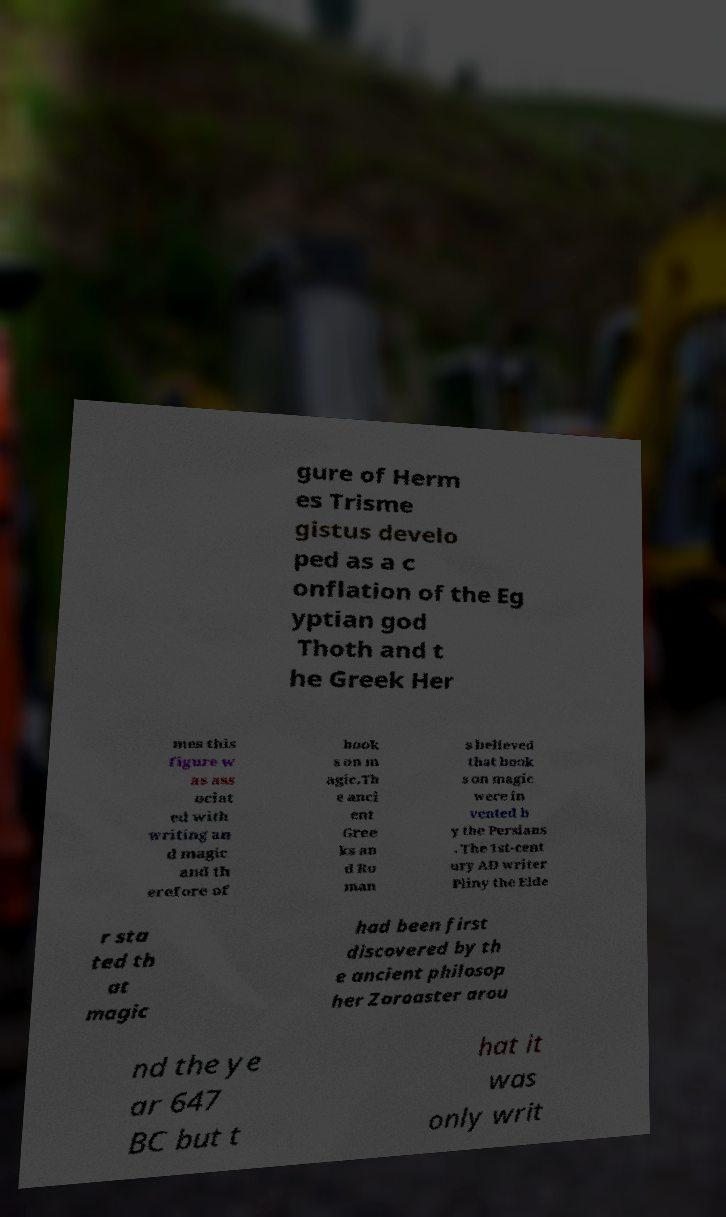Can you read and provide the text displayed in the image?This photo seems to have some interesting text. Can you extract and type it out for me? gure of Herm es Trisme gistus develo ped as a c onflation of the Eg yptian god Thoth and t he Greek Her mes this figure w as ass ociat ed with writing an d magic and th erefore of book s on m agic.Th e anci ent Gree ks an d Ro man s believed that book s on magic were in vented b y the Persians . The 1st-cent ury AD writer Pliny the Elde r sta ted th at magic had been first discovered by th e ancient philosop her Zoroaster arou nd the ye ar 647 BC but t hat it was only writ 